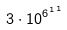<formula> <loc_0><loc_0><loc_500><loc_500>3 \cdot 1 0 ^ { { 6 ^ { 1 } } ^ { 1 } }</formula> 